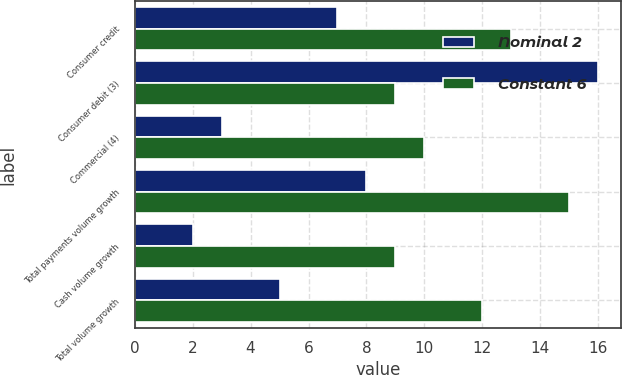Convert chart to OTSL. <chart><loc_0><loc_0><loc_500><loc_500><stacked_bar_chart><ecel><fcel>Consumer credit<fcel>Consumer debit (3)<fcel>Commercial (4)<fcel>Total payments volume growth<fcel>Cash volume growth<fcel>Total volume growth<nl><fcel>Nominal 2<fcel>7<fcel>16<fcel>3<fcel>8<fcel>2<fcel>5<nl><fcel>Constant 6<fcel>13<fcel>9<fcel>10<fcel>15<fcel>9<fcel>12<nl></chart> 